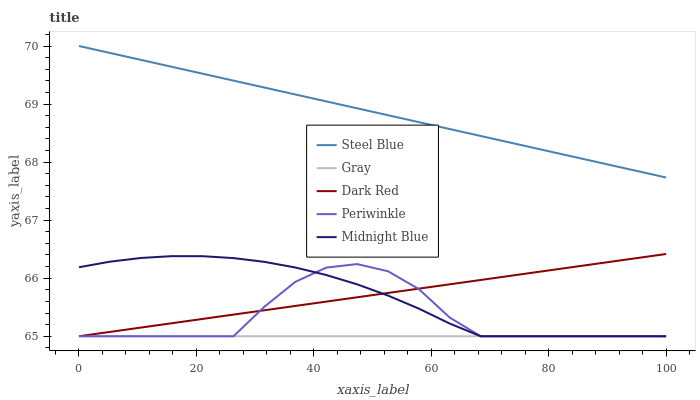Does Midnight Blue have the minimum area under the curve?
Answer yes or no. No. Does Midnight Blue have the maximum area under the curve?
Answer yes or no. No. Is Midnight Blue the smoothest?
Answer yes or no. No. Is Midnight Blue the roughest?
Answer yes or no. No. Does Steel Blue have the lowest value?
Answer yes or no. No. Does Midnight Blue have the highest value?
Answer yes or no. No. Is Periwinkle less than Steel Blue?
Answer yes or no. Yes. Is Steel Blue greater than Dark Red?
Answer yes or no. Yes. Does Periwinkle intersect Steel Blue?
Answer yes or no. No. 